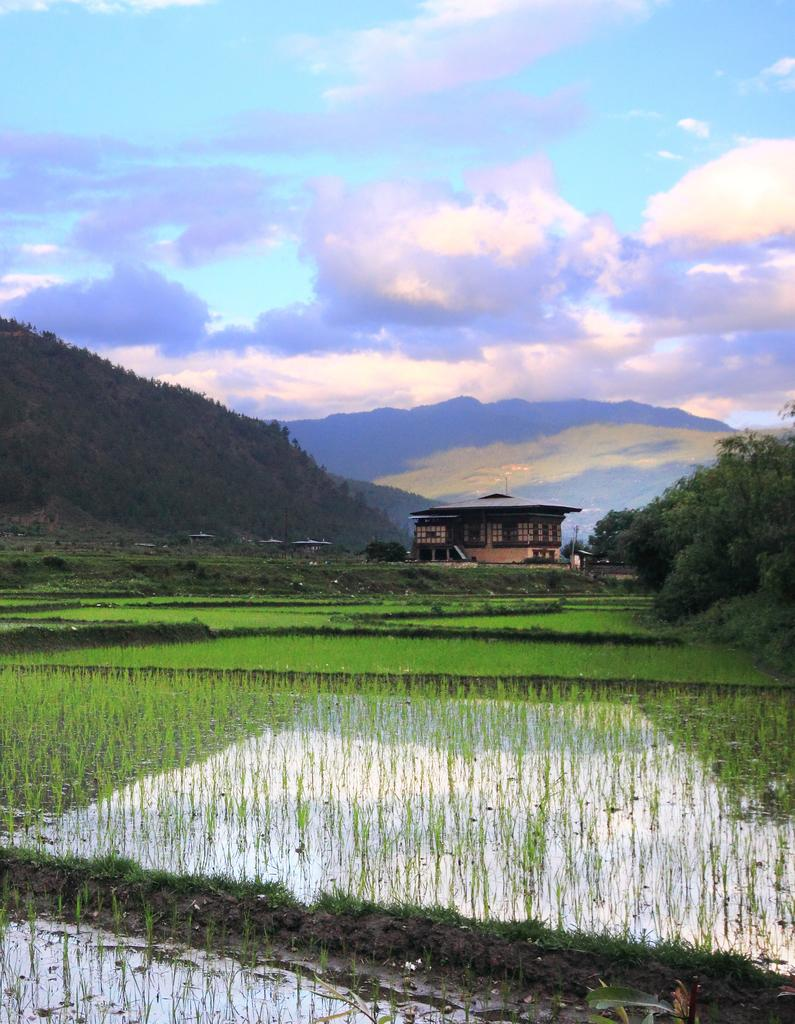What type of landscape is depicted in the image? There is a field in the image. What else can be seen in the image besides the field? There is water, a cottage in the background, mountains in the background, and clouds in the sky. How many ducks are swimming in the water in the image? There are no ducks present in the image; it only shows a field, water, a cottage, mountains, and clouds. 